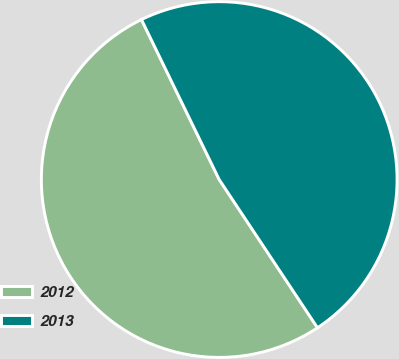Convert chart. <chart><loc_0><loc_0><loc_500><loc_500><pie_chart><fcel>2012<fcel>2013<nl><fcel>52.12%<fcel>47.88%<nl></chart> 